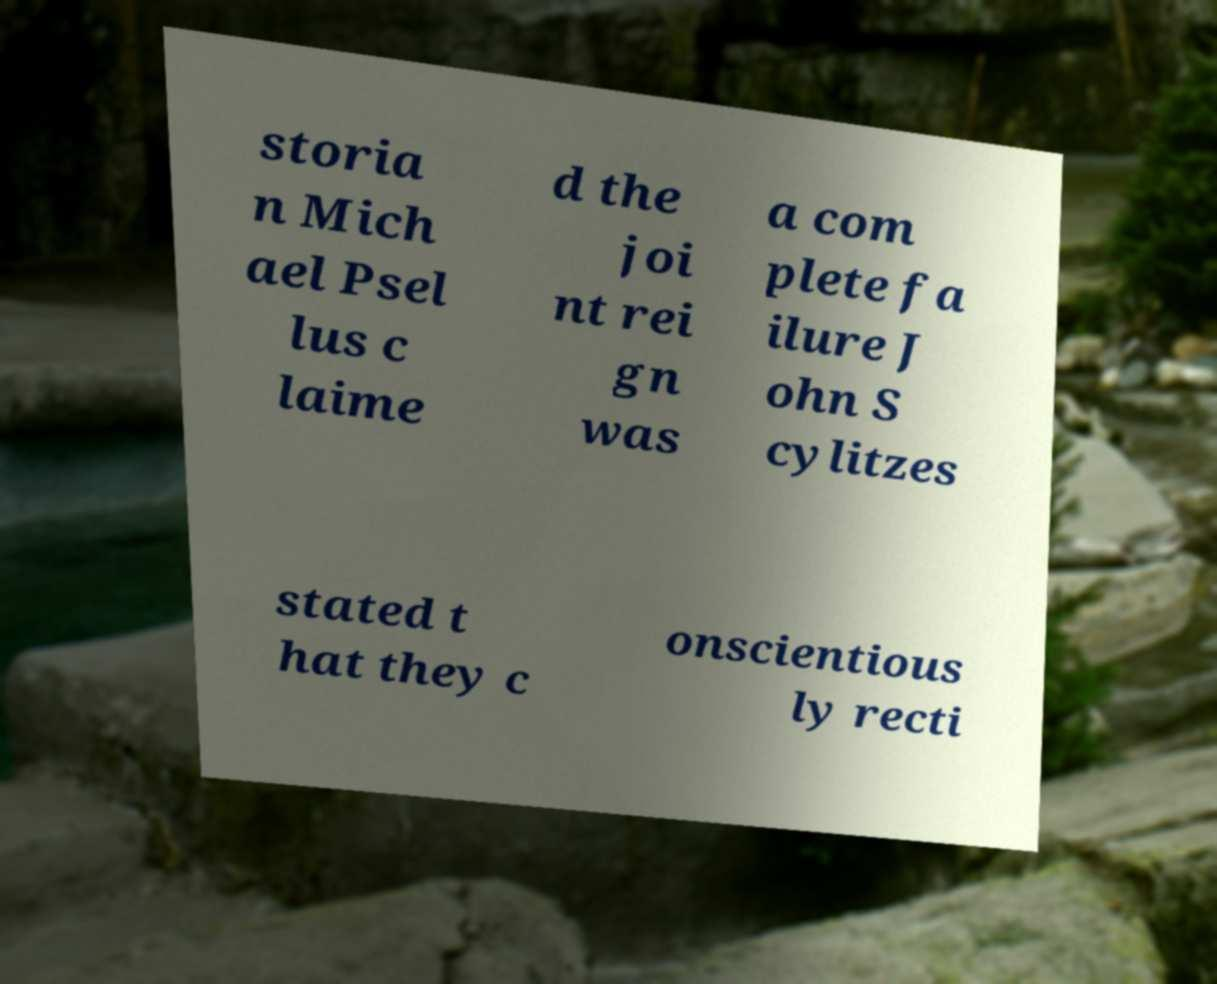There's text embedded in this image that I need extracted. Can you transcribe it verbatim? storia n Mich ael Psel lus c laime d the joi nt rei gn was a com plete fa ilure J ohn S cylitzes stated t hat they c onscientious ly recti 